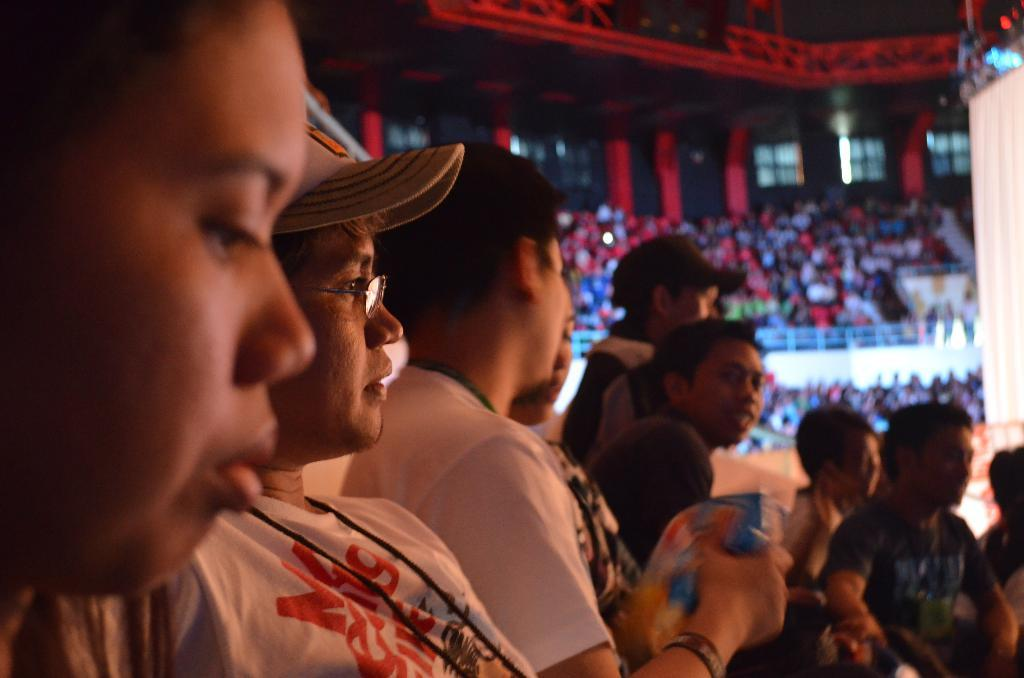What is located in the foreground of the image? There are people in the foreground of the image. What can be seen in the background of the image? There are people sitting in stands in the background of the image. How many cows are visible in the image? There are no cows present in the image; it features people in the foreground and stands in the background. What type of truck can be seen driving through the crowd in the image? There is no truck present in the image; it only features people in the foreground and stands in the background. 